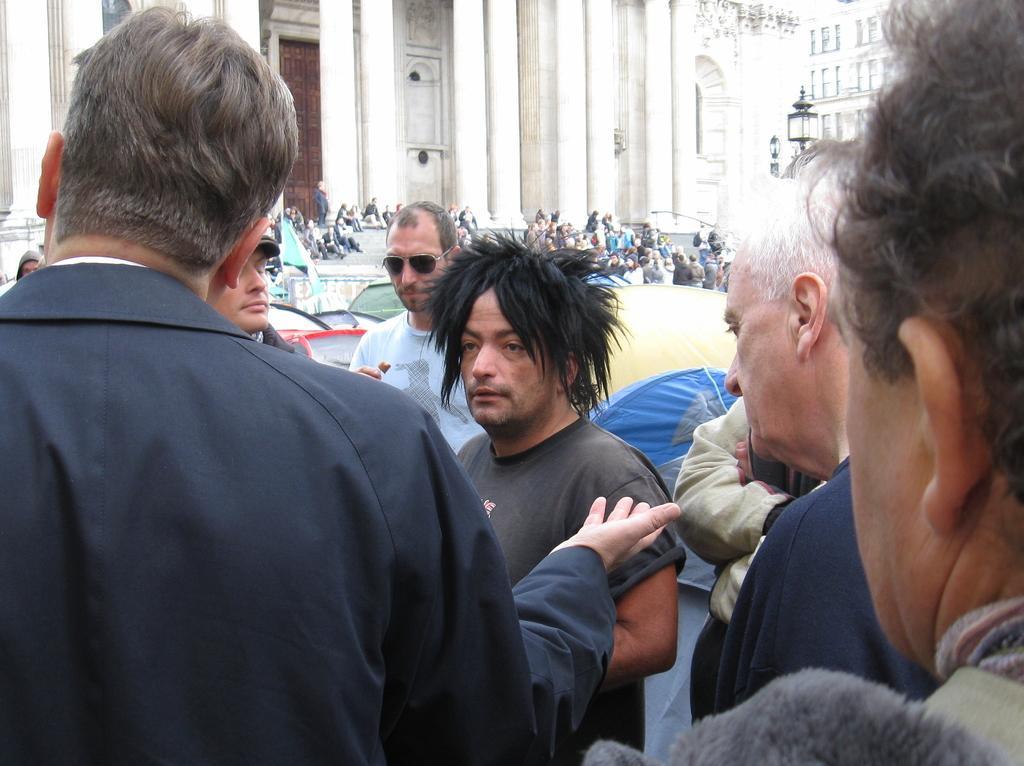Please provide a concise description of this image. There are many people. In the background there is a building with pillars. Also there are many people sitting on the steps. 